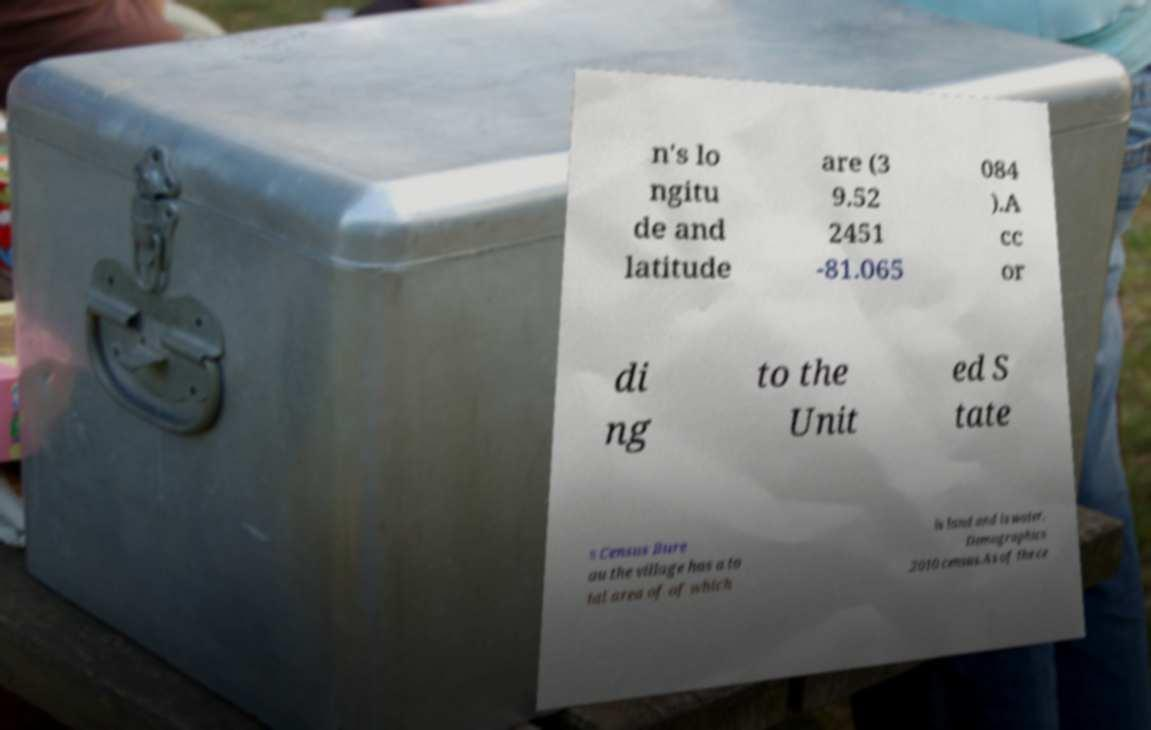For documentation purposes, I need the text within this image transcribed. Could you provide that? n's lo ngitu de and latitude are (3 9.52 2451 -81.065 084 ).A cc or di ng to the Unit ed S tate s Census Bure au the village has a to tal area of of which is land and is water. Demographics .2010 census.As of the ce 